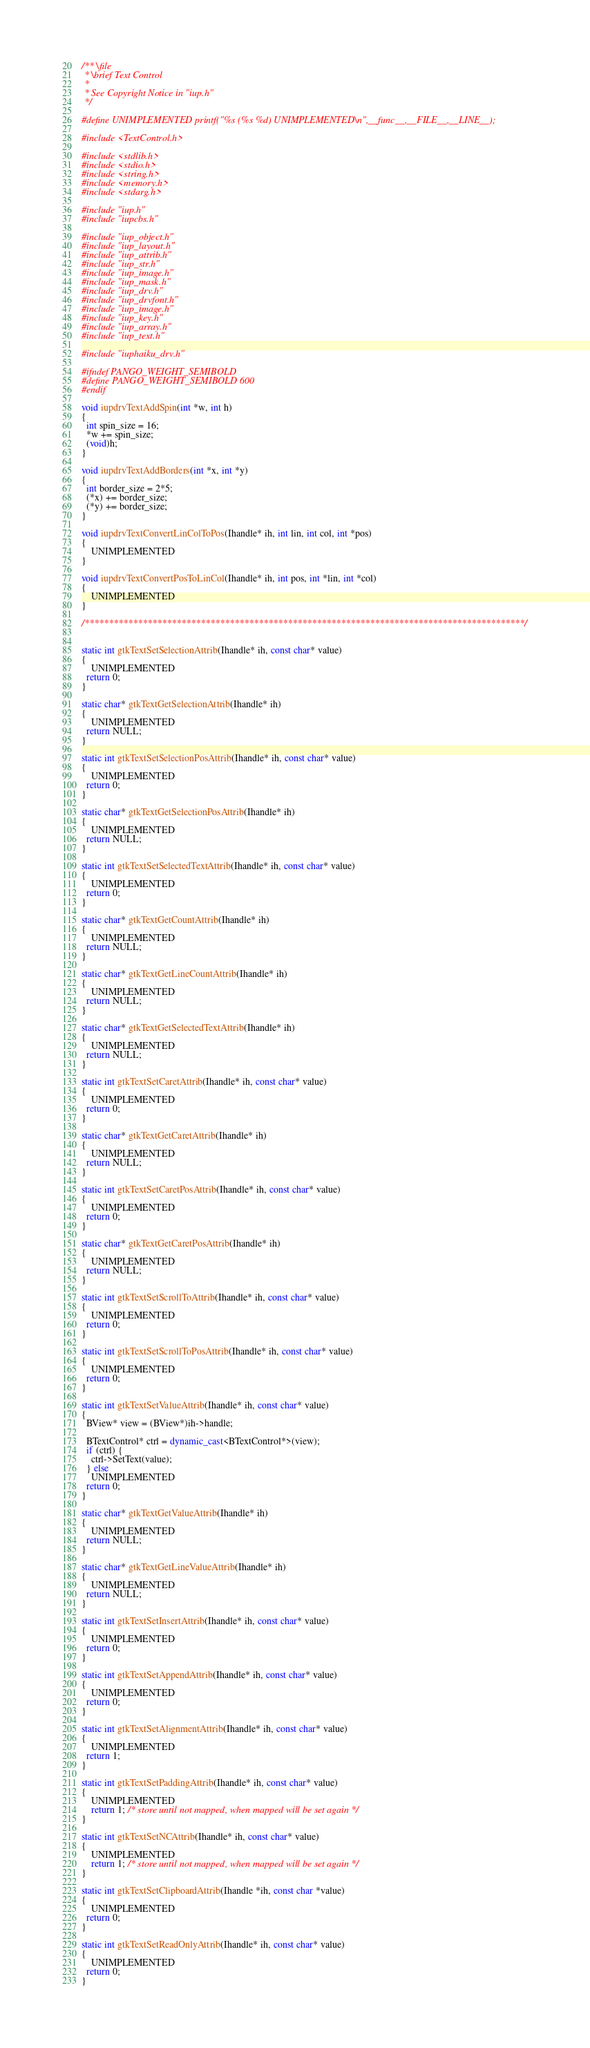<code> <loc_0><loc_0><loc_500><loc_500><_C++_>/** \file
 * \brief Text Control
 *
 * See Copyright Notice in "iup.h"
 */

#define UNIMPLEMENTED printf("%s (%s %d) UNIMPLEMENTED\n",__func__,__FILE__,__LINE__);

#include <TextControl.h>

#include <stdlib.h>
#include <stdio.h>
#include <string.h>
#include <memory.h>
#include <stdarg.h>

#include "iup.h"
#include "iupcbs.h"

#include "iup_object.h"
#include "iup_layout.h"
#include "iup_attrib.h"
#include "iup_str.h"
#include "iup_image.h"
#include "iup_mask.h"
#include "iup_drv.h"
#include "iup_drvfont.h"
#include "iup_image.h"
#include "iup_key.h"
#include "iup_array.h"
#include "iup_text.h"

#include "iuphaiku_drv.h"

#ifndef PANGO_WEIGHT_SEMIBOLD
#define PANGO_WEIGHT_SEMIBOLD 600
#endif

void iupdrvTextAddSpin(int *w, int h)
{
  int spin_size = 16;
  *w += spin_size;
  (void)h;
}

void iupdrvTextAddBorders(int *x, int *y)
{
  int border_size = 2*5;
  (*x) += border_size;
  (*y) += border_size;
}

void iupdrvTextConvertLinColToPos(Ihandle* ih, int lin, int col, int *pos)
{
	UNIMPLEMENTED
}

void iupdrvTextConvertPosToLinCol(Ihandle* ih, int pos, int *lin, int *col)
{
	UNIMPLEMENTED
}

/*******************************************************************************************/


static int gtkTextSetSelectionAttrib(Ihandle* ih, const char* value)
{
	UNIMPLEMENTED
  return 0;
}

static char* gtkTextGetSelectionAttrib(Ihandle* ih)
{
	UNIMPLEMENTED
  return NULL;
}

static int gtkTextSetSelectionPosAttrib(Ihandle* ih, const char* value)
{
	UNIMPLEMENTED
  return 0;
}

static char* gtkTextGetSelectionPosAttrib(Ihandle* ih)
{
	UNIMPLEMENTED
  return NULL;
}

static int gtkTextSetSelectedTextAttrib(Ihandle* ih, const char* value)
{
	UNIMPLEMENTED
  return 0;
}

static char* gtkTextGetCountAttrib(Ihandle* ih)
{
	UNIMPLEMENTED
  return NULL;
}

static char* gtkTextGetLineCountAttrib(Ihandle* ih)
{
	UNIMPLEMENTED
  return NULL;
}

static char* gtkTextGetSelectedTextAttrib(Ihandle* ih)
{
	UNIMPLEMENTED
  return NULL;
}

static int gtkTextSetCaretAttrib(Ihandle* ih, const char* value)
{
	UNIMPLEMENTED
  return 0;
}

static char* gtkTextGetCaretAttrib(Ihandle* ih)
{
	UNIMPLEMENTED
  return NULL;
}

static int gtkTextSetCaretPosAttrib(Ihandle* ih, const char* value)
{
	UNIMPLEMENTED
  return 0;
}

static char* gtkTextGetCaretPosAttrib(Ihandle* ih)
{
	UNIMPLEMENTED
  return NULL;
}

static int gtkTextSetScrollToAttrib(Ihandle* ih, const char* value)
{
	UNIMPLEMENTED
  return 0;
}

static int gtkTextSetScrollToPosAttrib(Ihandle* ih, const char* value)
{
	UNIMPLEMENTED
  return 0;
}

static int gtkTextSetValueAttrib(Ihandle* ih, const char* value)
{
  BView* view = (BView*)ih->handle;

  BTextControl* ctrl = dynamic_cast<BTextControl*>(view);
  if (ctrl) {
	ctrl->SetText(value);
  } else
	UNIMPLEMENTED
  return 0;
}

static char* gtkTextGetValueAttrib(Ihandle* ih)
{
	UNIMPLEMENTED
  return NULL;
}
                       
static char* gtkTextGetLineValueAttrib(Ihandle* ih)
{
	UNIMPLEMENTED
  return NULL;
}

static int gtkTextSetInsertAttrib(Ihandle* ih, const char* value)
{
	UNIMPLEMENTED
  return 0;
}

static int gtkTextSetAppendAttrib(Ihandle* ih, const char* value)
{
	UNIMPLEMENTED
  return 0;
}

static int gtkTextSetAlignmentAttrib(Ihandle* ih, const char* value)
{
	UNIMPLEMENTED
  return 1;
}

static int gtkTextSetPaddingAttrib(Ihandle* ih, const char* value)
{
	UNIMPLEMENTED
    return 1; /* store until not mapped, when mapped will be set again */
}

static int gtkTextSetNCAttrib(Ihandle* ih, const char* value)
{
	UNIMPLEMENTED
    return 1; /* store until not mapped, when mapped will be set again */
}

static int gtkTextSetClipboardAttrib(Ihandle *ih, const char *value)
{
	UNIMPLEMENTED
  return 0;
}

static int gtkTextSetReadOnlyAttrib(Ihandle* ih, const char* value)
{
	UNIMPLEMENTED
  return 0;
}
</code> 